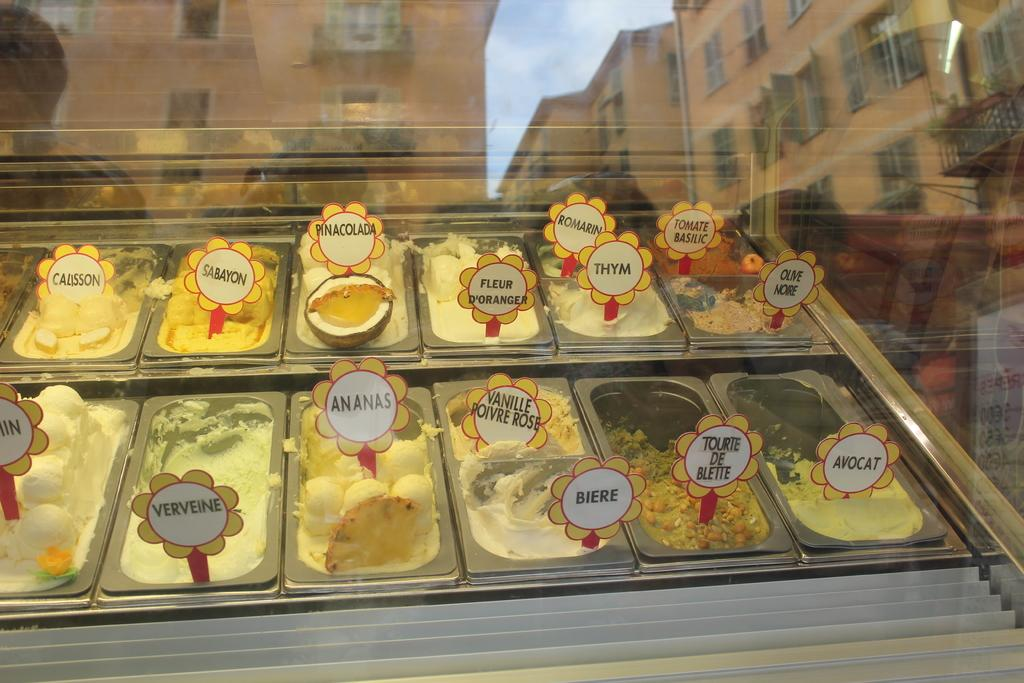What is the main object in the image? There is a glass in the image. What can be seen through the glass? Food items are visible in container boxes through the glass. What else can be seen in the glass? There are reflections of buildings and clouds in the sky in the glass. What type of debt is being discussed in the image? There is no mention of debt in the image; it features a glass with reflections and food items visible through it. 